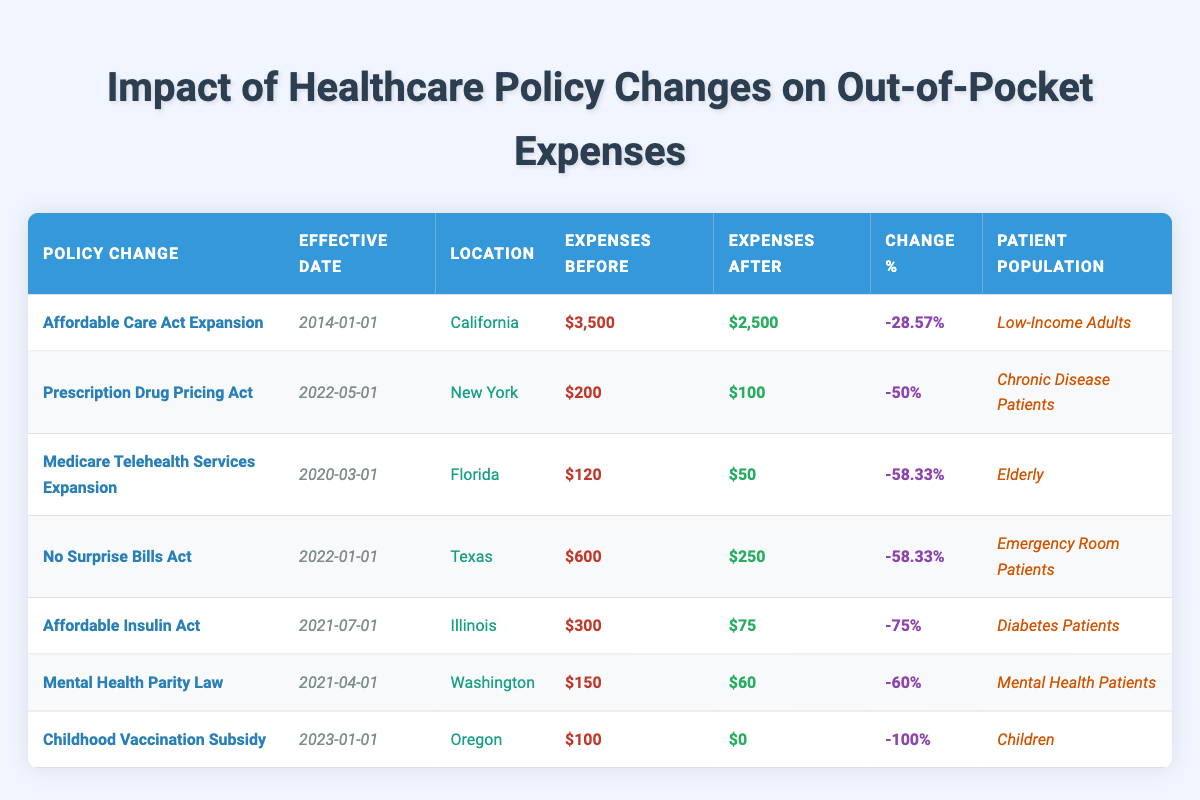What was the out-of-pocket expense for patients before the Affordable Care Act Expansion? According to the table, before the Affordable Care Act Expansion, the out-of-pocket expenses for patients were $3,500.
Answer: $3,500 Which policy change resulted in the largest percentage decrease in out-of-pocket expenses? The policy change that resulted in the largest percentage decrease in out-of-pocket expenses was the Affordable Insulin Act, which had a change percentage of -75%.
Answer: Affordable Insulin Act True or False: The No Surprise Bills Act occurred before the Prescription Drug Pricing Act. Looking at the effective dates in the table, the No Surprise Bills Act’s effective date was 2022-01-01, while the Prescription Drug Pricing Act was 2022-05-01. Thus, the statement is true.
Answer: True What are the total out-of-pocket expenses before the policy changes for Chronic Disease Patients and Mental Health Patients? The out-of-pocket expenses before the policy changes for Chronic Disease Patients (Prescription Drug Pricing Act) is $200, and for Mental Health Patients (Mental Health Parity Law), it's $150. Adding them gives $200 + $150 = $350.
Answer: $350 How many patient populations saw a decrease in out-of-pocket expenses of over 50%? From the table, the patient populations that saw a decrease in out-of-pocket expenses of over 50% are Chronic Disease Patients, Elderly, Emergency Room Patients, Diabetes Patients, Mental Health Patients, and Children. Counting these gives a total of 6 populations.
Answer: 6 Which location had the highest out-of-pocket expenses after legislation changes? Reviewing the table, the location with the highest out-of-pocket expenses after legislation changes is Texas, with expenses of $250 after the No Surprise Bills Act.
Answer: Texas What was the average out-of-pocket expense reduction for all policies listed? To calculate the average reduction, we first find the total out-of-pocket expenses before and after the changes. Total before: $3,500 (ACA) + $200 (Drug Pricing) + $120 (Telehealth) + $600 (Surprise Bills) + $300 (Insulin) + $150 (Mental Health) + $100 (Vaccinations) = $5,070. Total after: $2,500 (ACA) + $100 (Drug Pricing) + $50 (Telehealth) + $250 (Surprise Bills) + $75 (Insulin) + $60 (Mental Health) + $0 (Vaccinations) = $3,035. The total reduction is $5,070 - $3,035 = $2,035. There are 7 policies, so the average reduction is $2,035 / 7 ≈ $290.71.
Answer: $290.71 True or False: The Childhood Vaccination Subsidy eliminated all out-of-pocket expenses for children. The table indicates that the out-of-pocket expenses for the Childhood Vaccination Subsidy decreased from $100 to $0, confirming that it eliminated all out-of-pocket expenses for children. Therefore, the statement is true.
Answer: True 